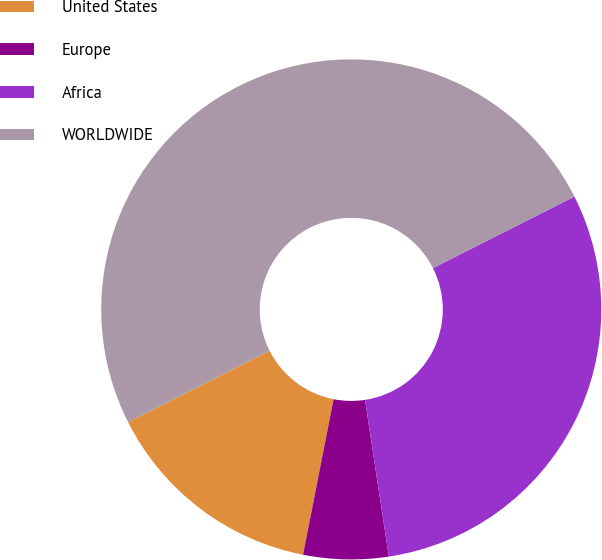Convert chart. <chart><loc_0><loc_0><loc_500><loc_500><pie_chart><fcel>United States<fcel>Europe<fcel>Africa<fcel>WORLDWIDE<nl><fcel>14.46%<fcel>5.49%<fcel>30.05%<fcel>50.0%<nl></chart> 